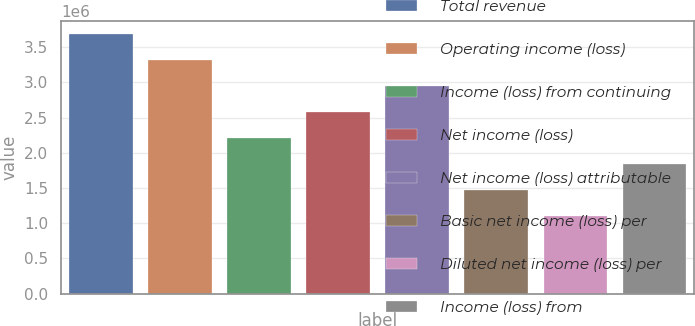Convert chart to OTSL. <chart><loc_0><loc_0><loc_500><loc_500><bar_chart><fcel>Total revenue<fcel>Operating income (loss)<fcel>Income (loss) from continuing<fcel>Net income (loss)<fcel>Net income (loss) attributable<fcel>Basic net income (loss) per<fcel>Diluted net income (loss) per<fcel>Income (loss) from<nl><fcel>3.67935e+06<fcel>3.31142e+06<fcel>2.20761e+06<fcel>2.57555e+06<fcel>2.94348e+06<fcel>1.47174e+06<fcel>1.10381e+06<fcel>1.83968e+06<nl></chart> 